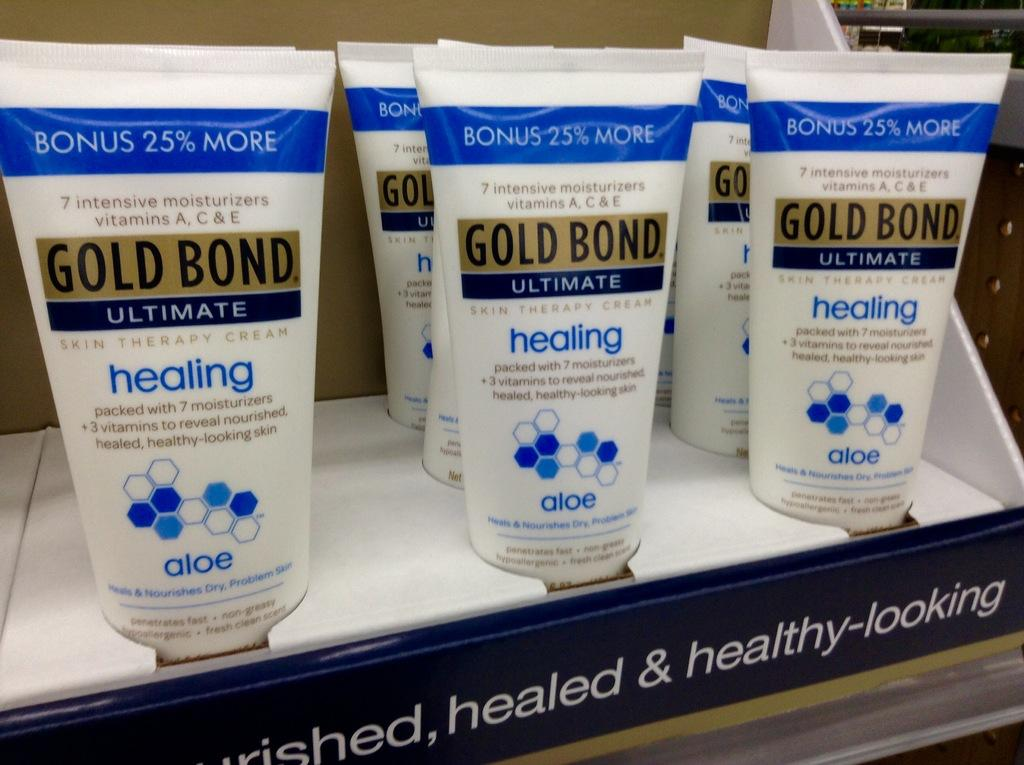<image>
Give a short and clear explanation of the subsequent image. a display of GOLD BoND ultimate healing lotion 